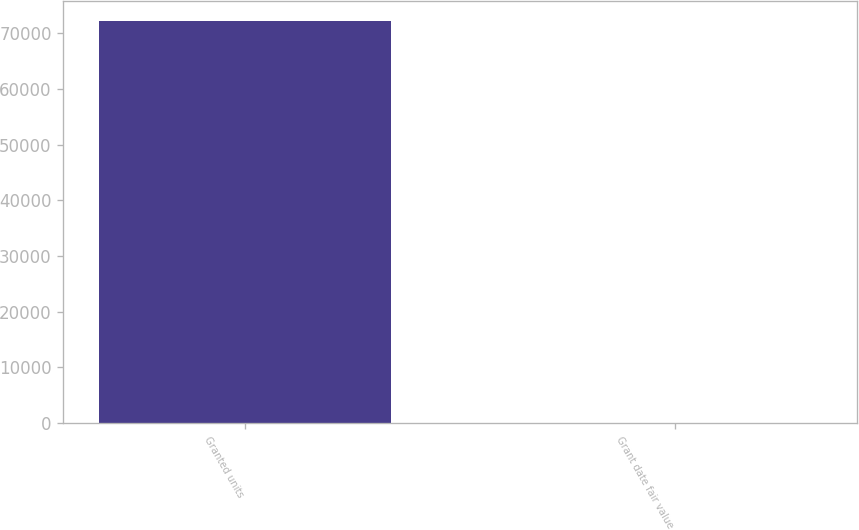Convert chart to OTSL. <chart><loc_0><loc_0><loc_500><loc_500><bar_chart><fcel>Granted units<fcel>Grant date fair value<nl><fcel>72185<fcel>17.87<nl></chart> 